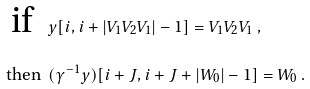<formula> <loc_0><loc_0><loc_500><loc_500>\text {if } \ & y [ i , i + | V _ { 1 } V _ { 2 } V _ { 1 } | - 1 ] = V _ { 1 } V _ { 2 } V _ { 1 } \ , \\ \text { then } \ & ( \gamma ^ { - 1 } y ) [ i + J , i + J + | W _ { 0 } | - 1 ] = W _ { 0 } \ .</formula> 